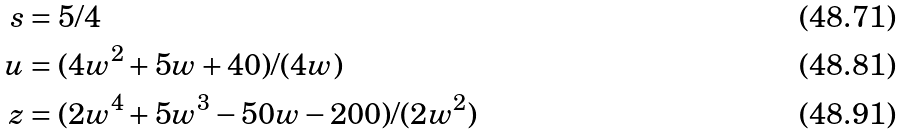Convert formula to latex. <formula><loc_0><loc_0><loc_500><loc_500>s & = 5 / 4 \\ u & = ( 4 w ^ { 2 } + 5 w + 4 0 ) / ( 4 w ) \\ z & = ( 2 w ^ { 4 } + 5 w ^ { 3 } - 5 0 w - 2 0 0 ) / ( 2 w ^ { 2 } )</formula> 